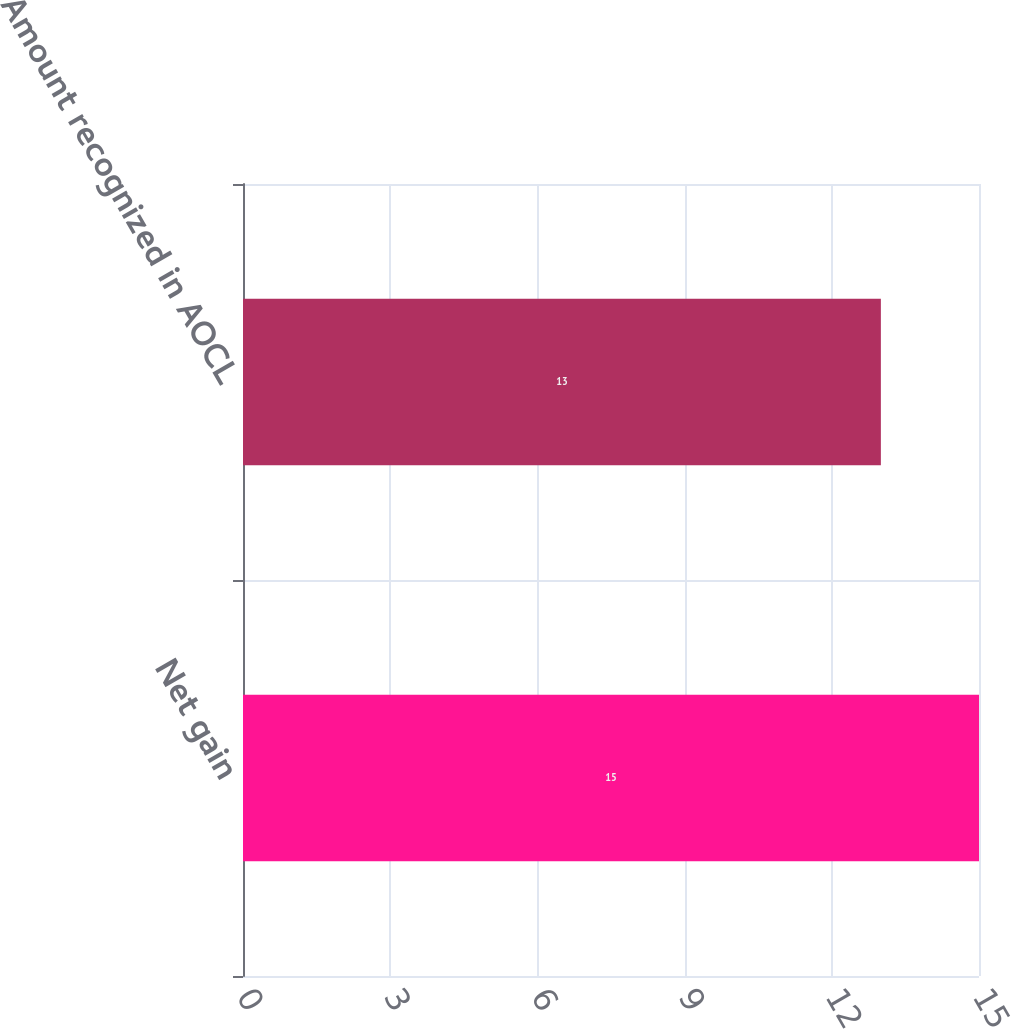<chart> <loc_0><loc_0><loc_500><loc_500><bar_chart><fcel>Net gain<fcel>Amount recognized in AOCL<nl><fcel>15<fcel>13<nl></chart> 